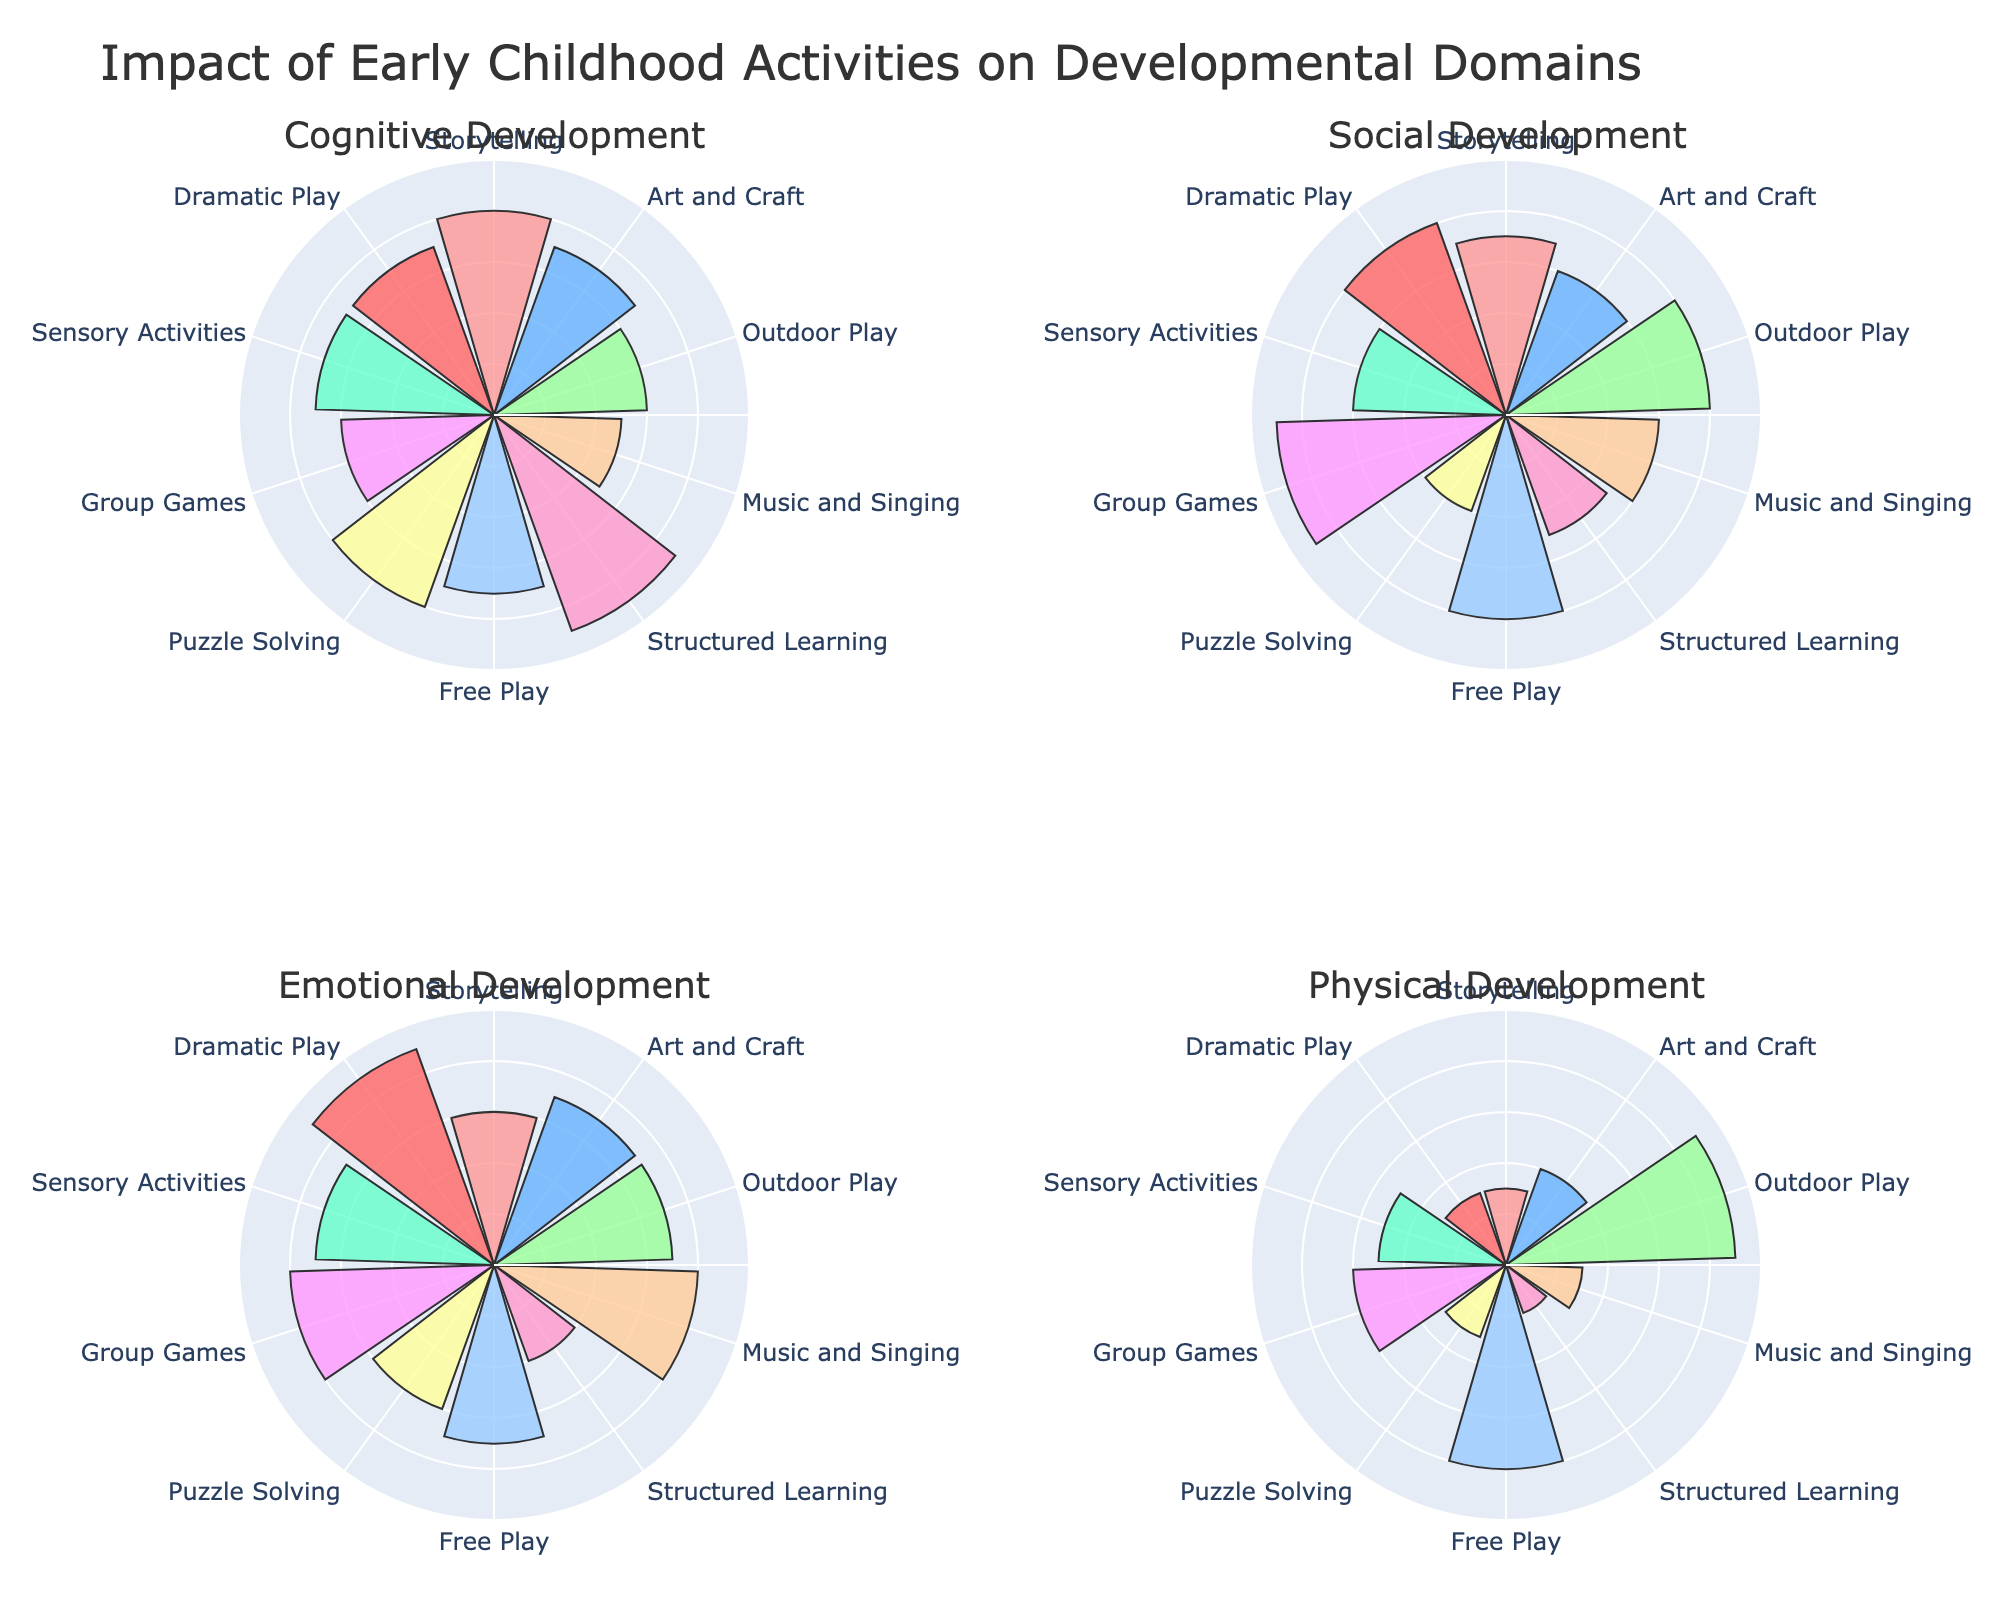What is the title of the figure? The title is displayed at the top of the figure.
Answer: Impact of Early Childhood Activities on Developmental Domains Which activities have the highest frequency per week? By examining the radial length in "Frequency per Week" subplots, we see that 'Free Play' and 'Storytelling' have the largest radial lengths, indicating the highest frequency.
Answer: Free Play and Storytelling Which activity has the highest impact on physical development? Inspect the radial plot for "Physical Development". 'Outdoor Play' shows the largest radial length, indicating the highest impact.
Answer: Outdoor Play How does the impact of storytelling on cognitive development compare to its impact on social development? Check the radial lengths for 'Storytelling' in "Cognitive Development" and "Social Development". The radial length for cognitive development is 8, and for social development, it is 7.
Answer: Higher for cognitive development Which developmental domain benefits the most from group games? Look at the radial lengths in the "Group Games" section across each developmental domain. The radial length for "Social Development" is the longest, indicating the highest benefit.
Answer: Social Development Which activity shows equal impact on social and emotional development? Scan each subplot for equal radial lengths in "Social Development" and "Emotional Development". 'Music and Singing' has 6 in both domains.
Answer: Music and Singing What’s the average impact of sensory activities across all developmental domains? Add up the radial lengths for 'Sensory Activities' in all domains (7+6+7+5) and divide by 4.
Answer: 6.25 Compare the impact of structured learning on emotional and physical development. Which is higher? Look at the radial lengths for 'Structured Learning' in "Emotional Development" and "Physical Development", which are 4 and 2, respectively.
Answer: Emotional Development Which activity has the lowest impact on emotional development? Look for the shortest radial length in the "Emotional Development" subplot, which is 'Structured Learning' with 4.
Answer: Structured Learning Is there any activity that ranks equally high in both cognitive and physical development? Compare the radial lengths in "Cognitive Development" and "Physical Development". None of them rank equally high.
Answer: No 